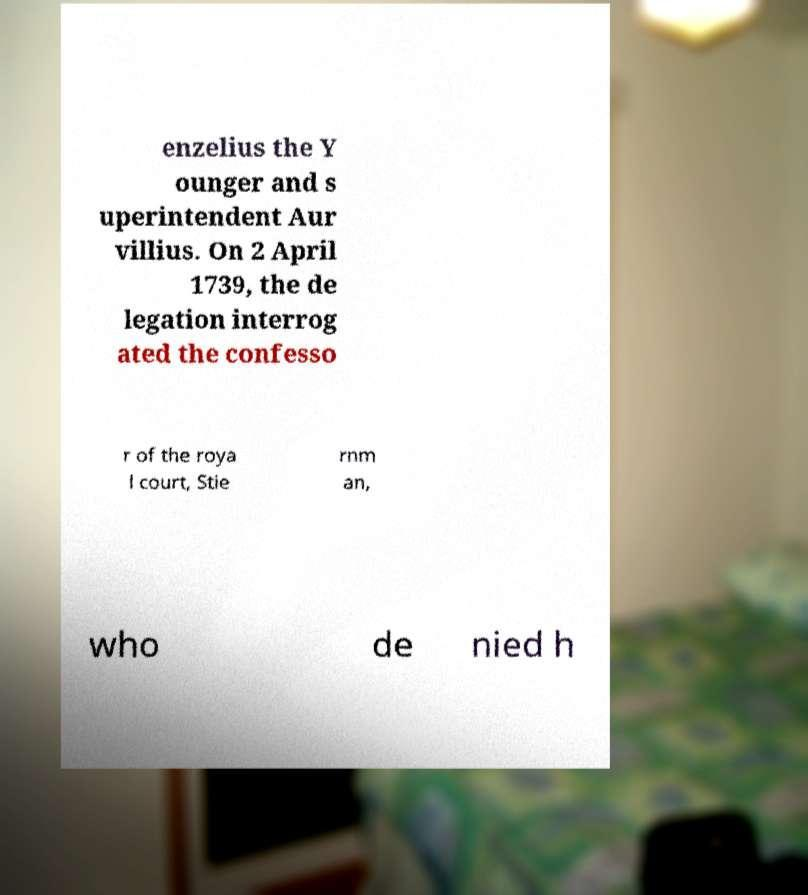Can you accurately transcribe the text from the provided image for me? enzelius the Y ounger and s uperintendent Aur villius. On 2 April 1739, the de legation interrog ated the confesso r of the roya l court, Stie rnm an, who de nied h 